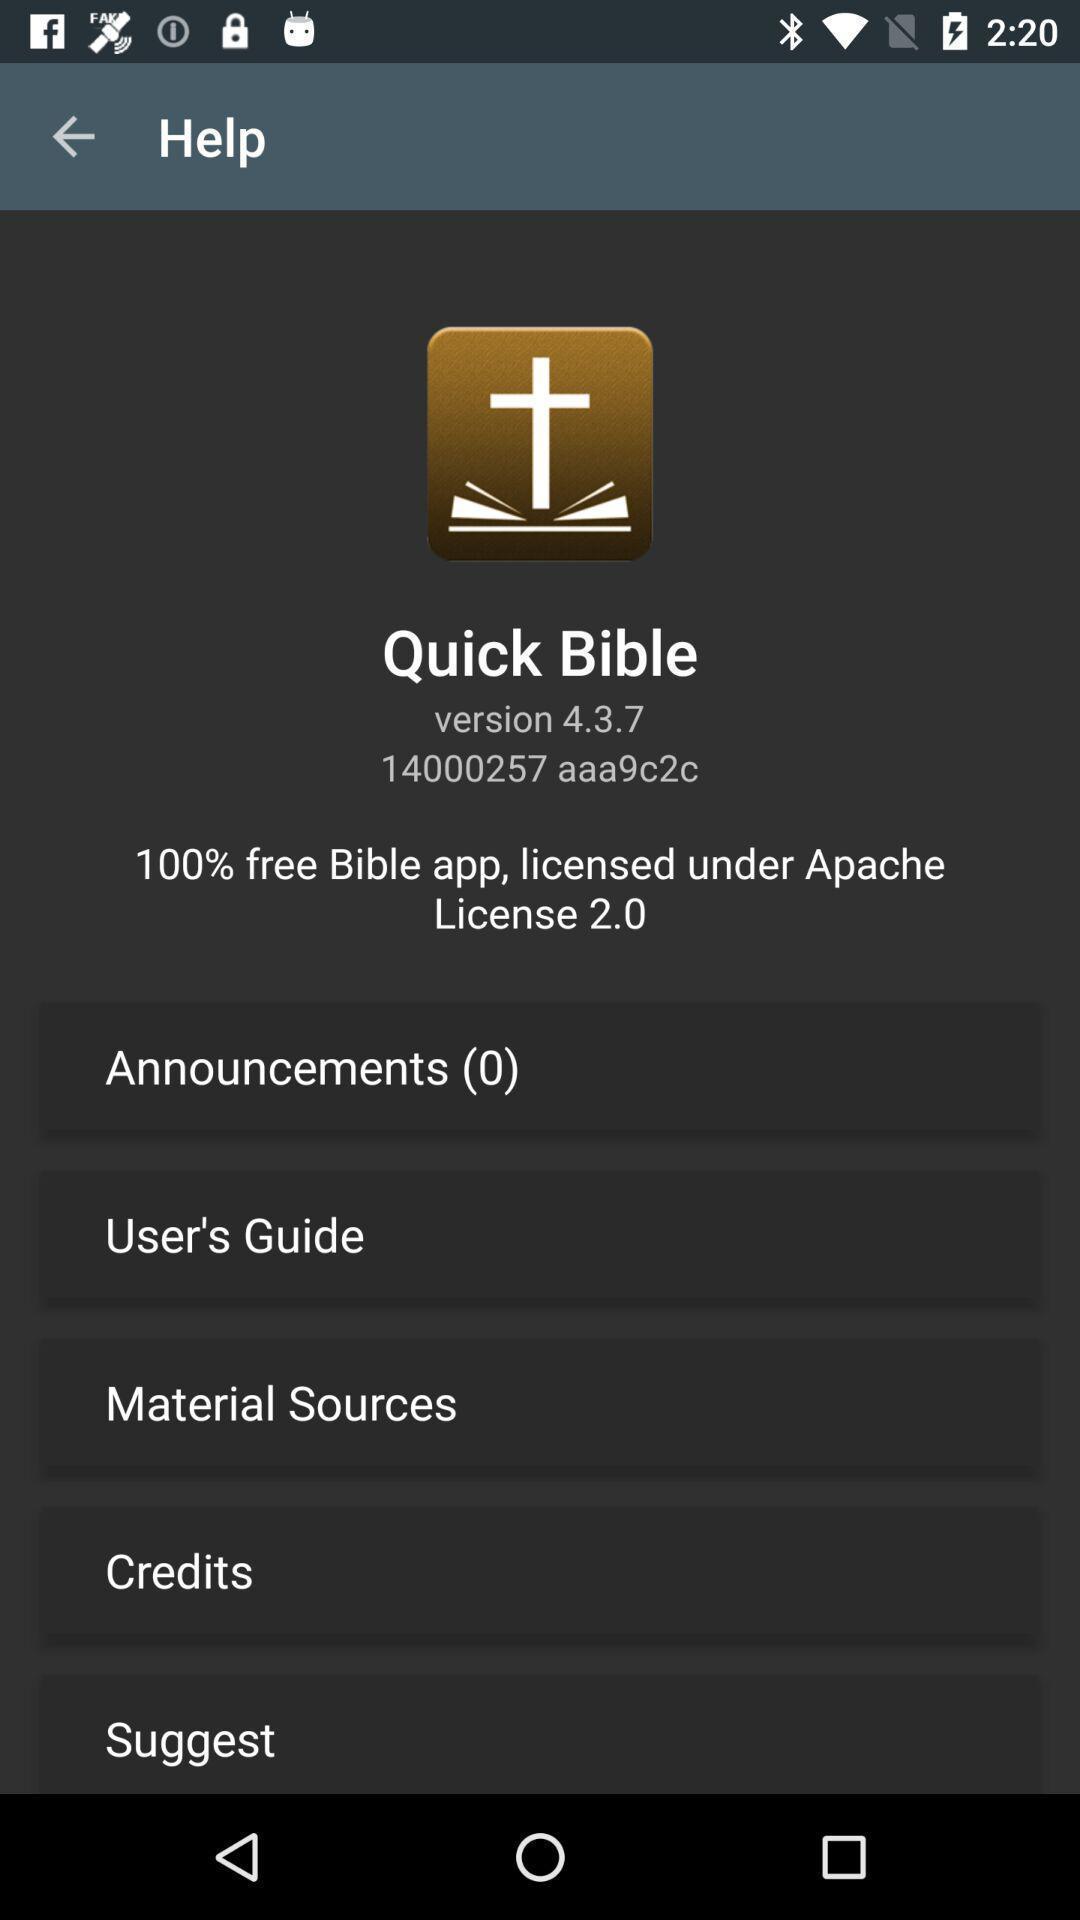Describe the key features of this screenshot. Help page with options. 